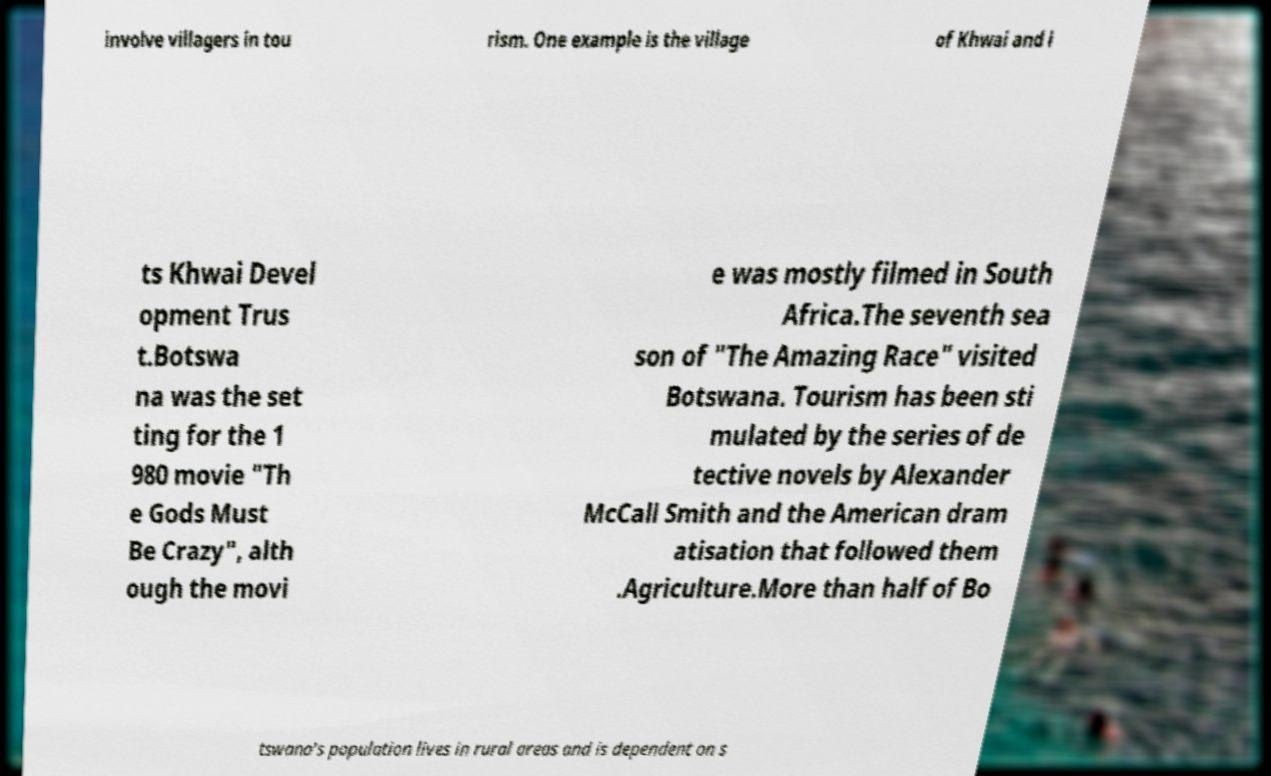Please identify and transcribe the text found in this image. involve villagers in tou rism. One example is the village of Khwai and i ts Khwai Devel opment Trus t.Botswa na was the set ting for the 1 980 movie "Th e Gods Must Be Crazy", alth ough the movi e was mostly filmed in South Africa.The seventh sea son of "The Amazing Race" visited Botswana. Tourism has been sti mulated by the series of de tective novels by Alexander McCall Smith and the American dram atisation that followed them .Agriculture.More than half of Bo tswana's population lives in rural areas and is dependent on s 